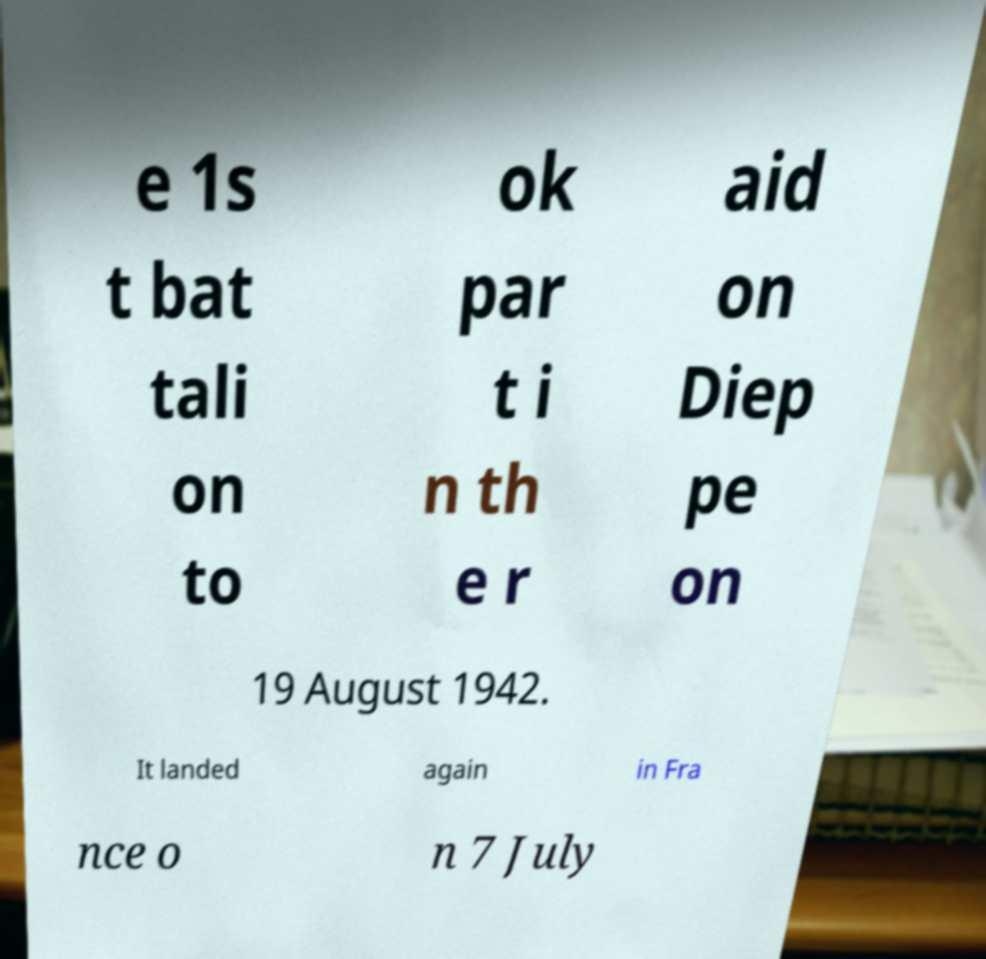Please identify and transcribe the text found in this image. e 1s t bat tali on to ok par t i n th e r aid on Diep pe on 19 August 1942. It landed again in Fra nce o n 7 July 